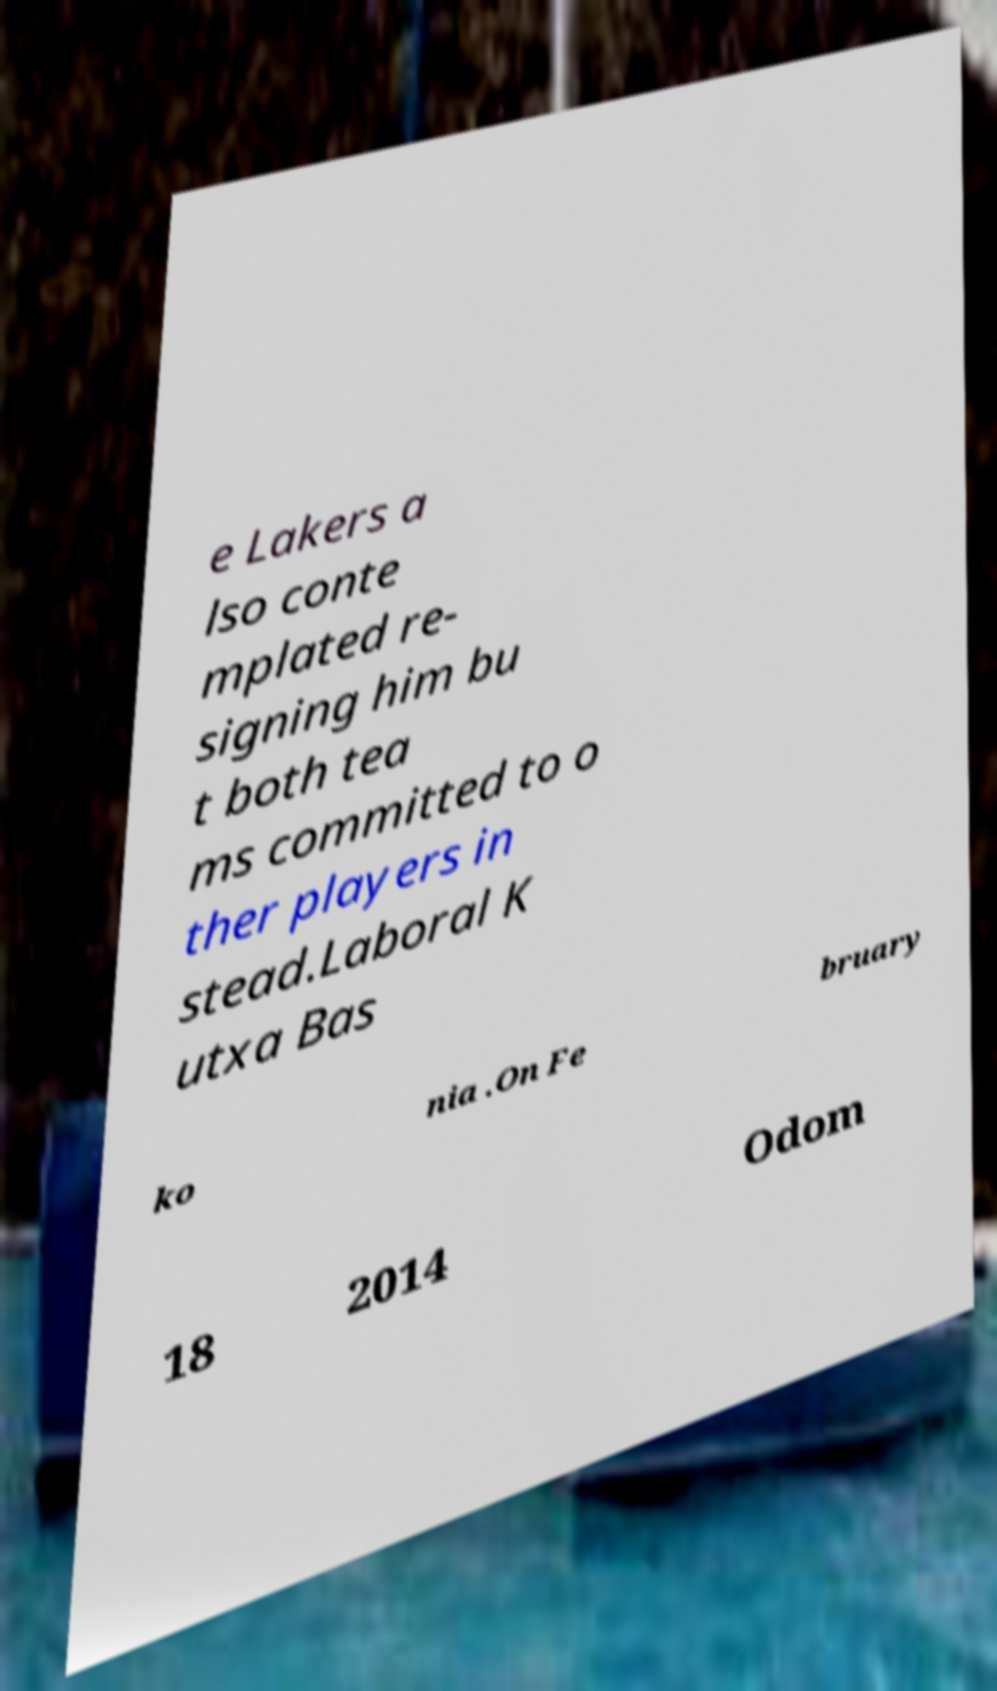Please identify and transcribe the text found in this image. e Lakers a lso conte mplated re- signing him bu t both tea ms committed to o ther players in stead.Laboral K utxa Bas ko nia .On Fe bruary 18 2014 Odom 